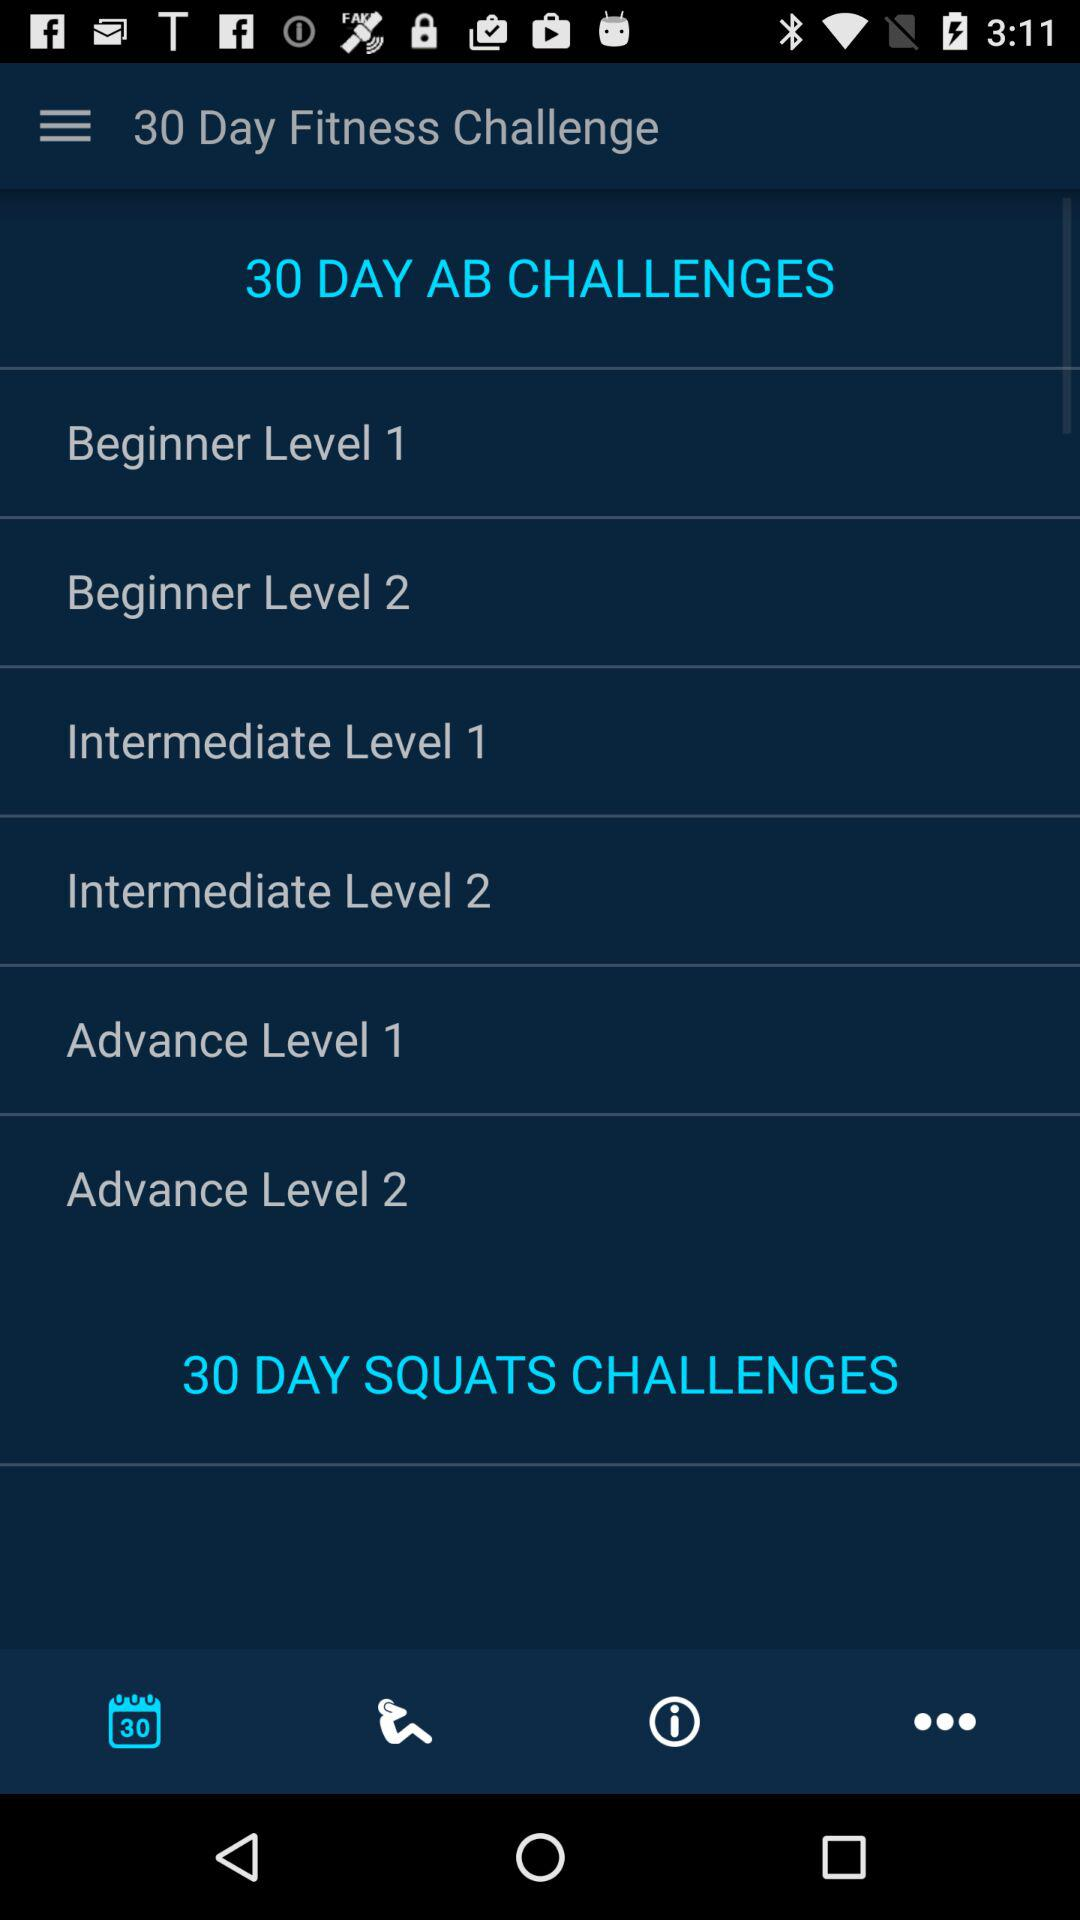What are the different levels of "30 DAY AB CHALLENGES"? The different levels of "30 DAY AB CHALLENGES" are "Beginner Level 1", "Beginner Level 2", "Intermediate Level 1", "Intermediate Level 2", "Advance Level 1" and "Advance Level 2". 